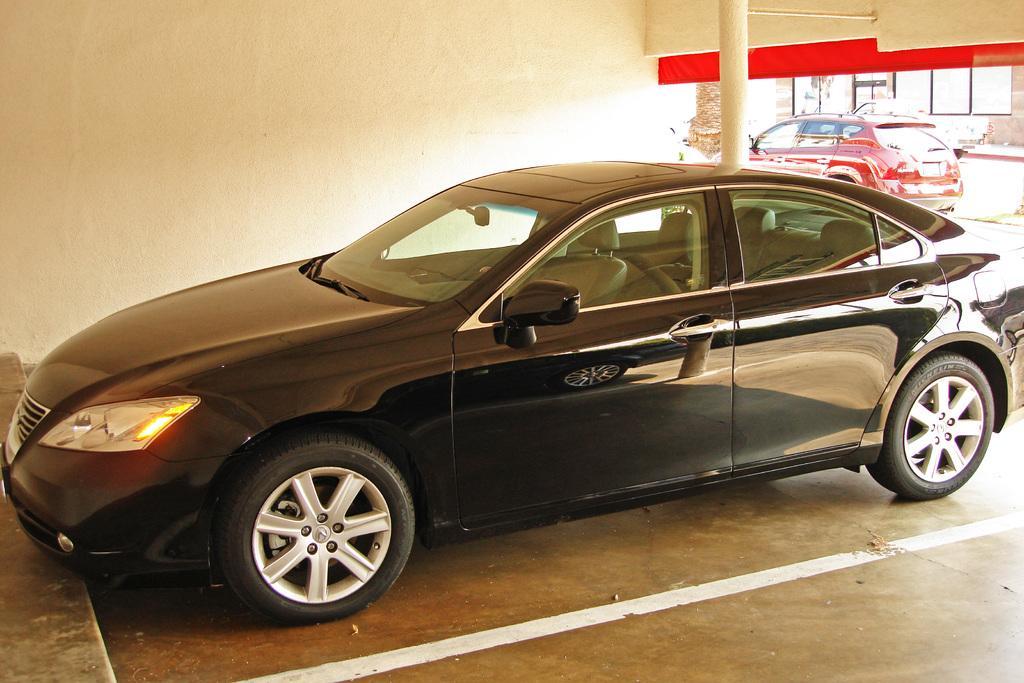Please provide a concise description of this image. In the middle of the picture, we see a black color car is parked in the parking lot. In front of the car, we see a staircase. Beside the car, we see a white wall and a pole. On the right side, we see a red car is moving on the road. Beside that, we see a building. 